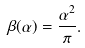Convert formula to latex. <formula><loc_0><loc_0><loc_500><loc_500>\beta ( \alpha ) = \frac { \alpha ^ { 2 } } { \pi } .</formula> 